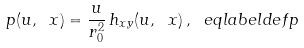Convert formula to latex. <formula><loc_0><loc_0><loc_500><loc_500>\ p ( u , \ x ) = \frac { u } { r _ { 0 } ^ { 2 } } \, h _ { x y } ( u , \ x ) \, , \ e q l a b e l { d e f p }</formula> 